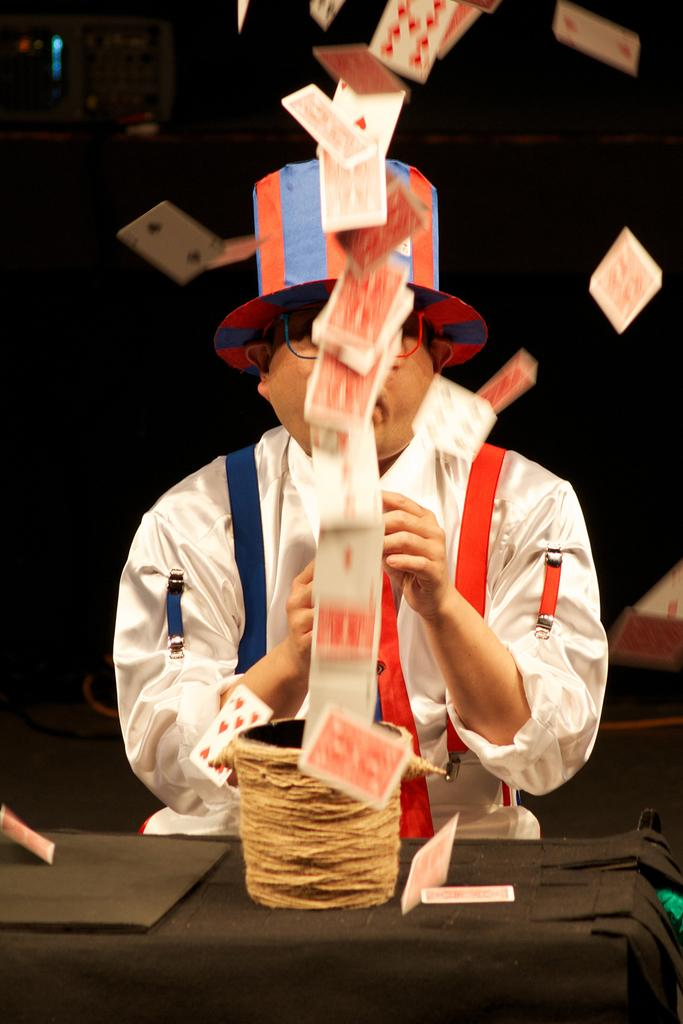Who is present in the image? There is a man in the image. What is the man wearing on his head? The man is wearing a hat. What type of eyewear is the man wearing? The man is wearing glasses (specs). What objects can be seen in the image besides the man? There are cards visible in the image. What type of unit is the man operating in the image? There is no indication of a unit or any military context in the image. What game is the man playing in the image? The image does not show the man playing a game or any specific activity. 